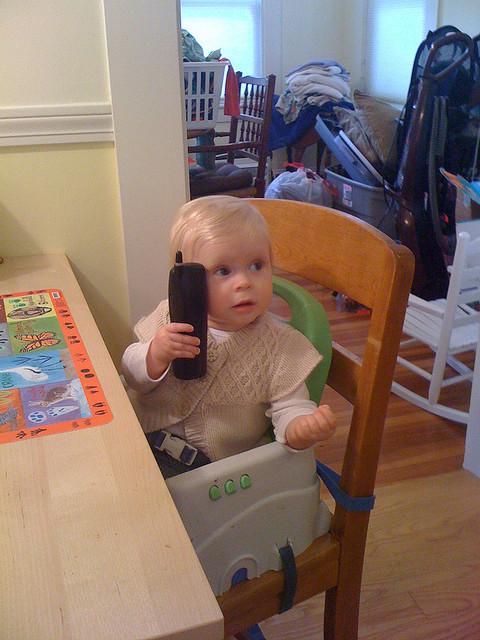What is the child holding?
Keep it brief. Phone. Is this indoors or outside?
Concise answer only. Indoors. Where is the white and green infant seat?
Give a very brief answer. On chair. What is the baby holding up to it's face?
Answer briefly. Phone. 